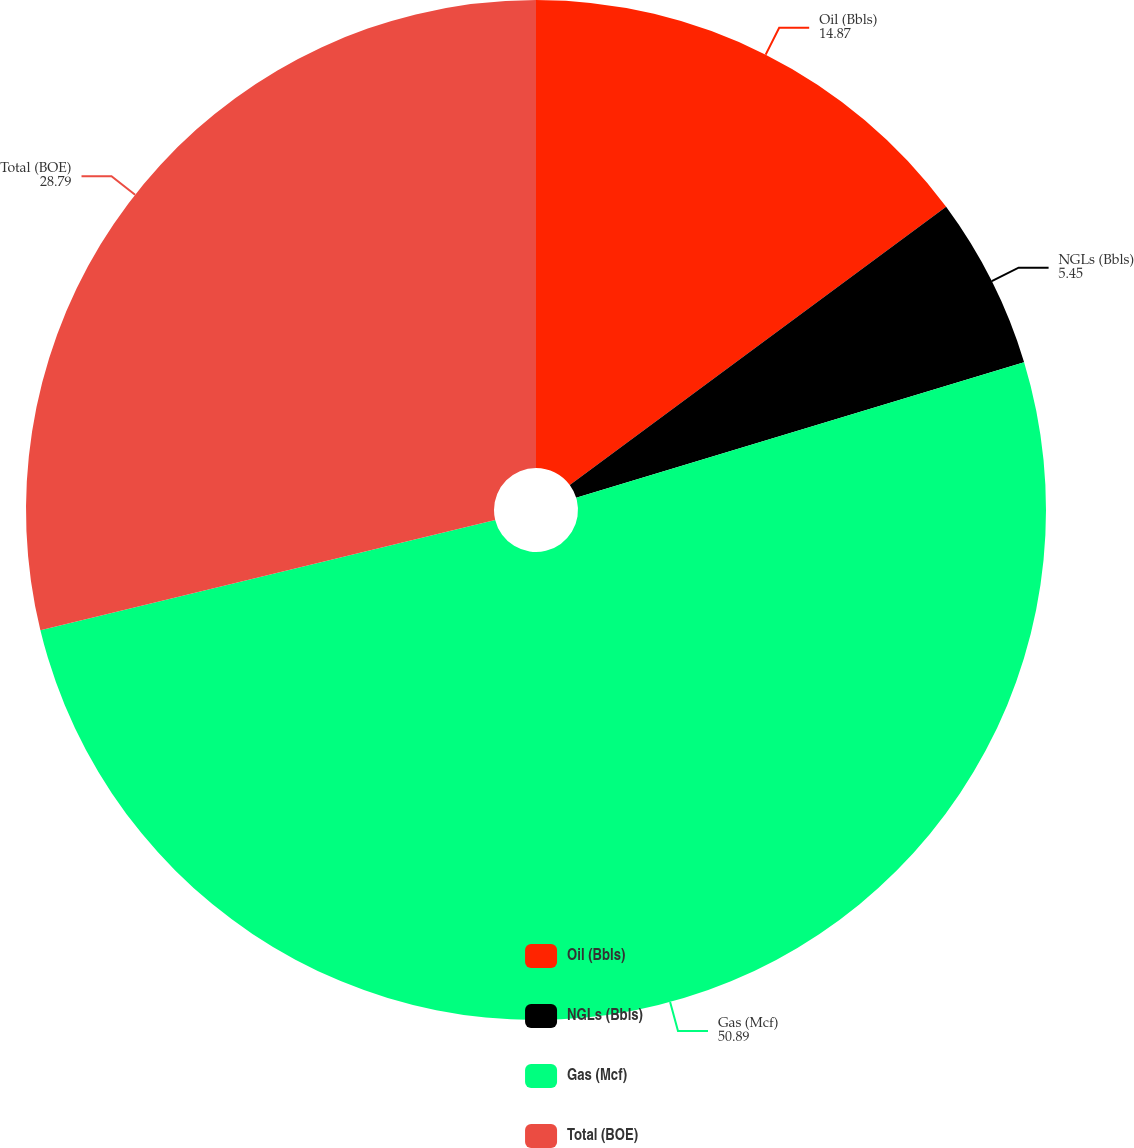<chart> <loc_0><loc_0><loc_500><loc_500><pie_chart><fcel>Oil (Bbls)<fcel>NGLs (Bbls)<fcel>Gas (Mcf)<fcel>Total (BOE)<nl><fcel>14.87%<fcel>5.45%<fcel>50.89%<fcel>28.79%<nl></chart> 